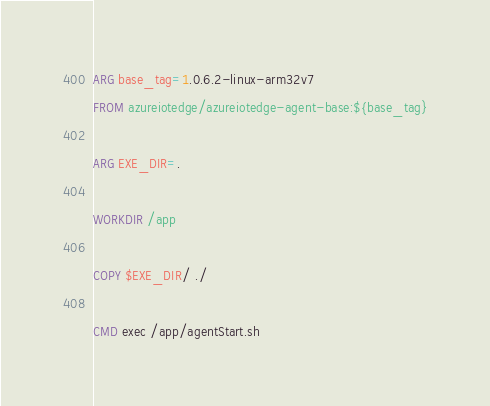<code> <loc_0><loc_0><loc_500><loc_500><_Dockerfile_>ARG base_tag=1.0.6.2-linux-arm32v7
FROM azureiotedge/azureiotedge-agent-base:${base_tag}

ARG EXE_DIR=.

WORKDIR /app

COPY $EXE_DIR/ ./

CMD exec /app/agentStart.sh
</code> 